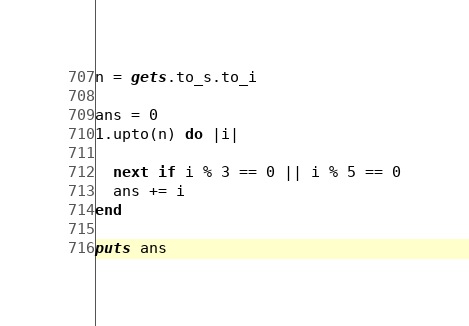Convert code to text. <code><loc_0><loc_0><loc_500><loc_500><_Crystal_>n = gets.to_s.to_i
 
ans = 0
1.upto(n) do |i|
  
  next if i % 3 == 0 || i % 5 == 0
  ans += i
end
 
puts ans</code> 